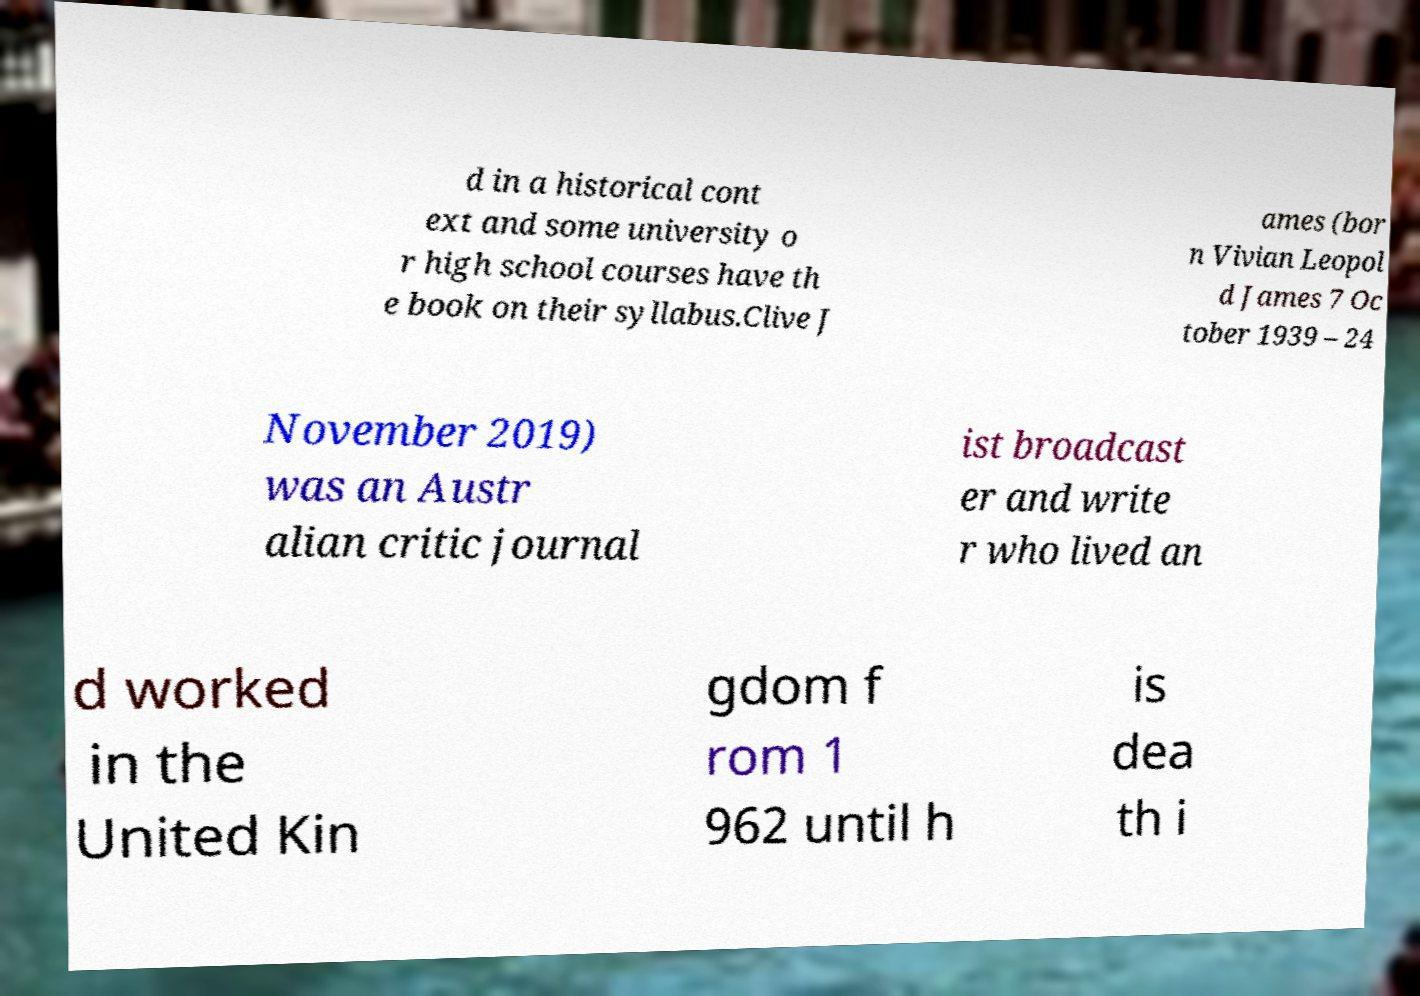Please identify and transcribe the text found in this image. d in a historical cont ext and some university o r high school courses have th e book on their syllabus.Clive J ames (bor n Vivian Leopol d James 7 Oc tober 1939 – 24 November 2019) was an Austr alian critic journal ist broadcast er and write r who lived an d worked in the United Kin gdom f rom 1 962 until h is dea th i 